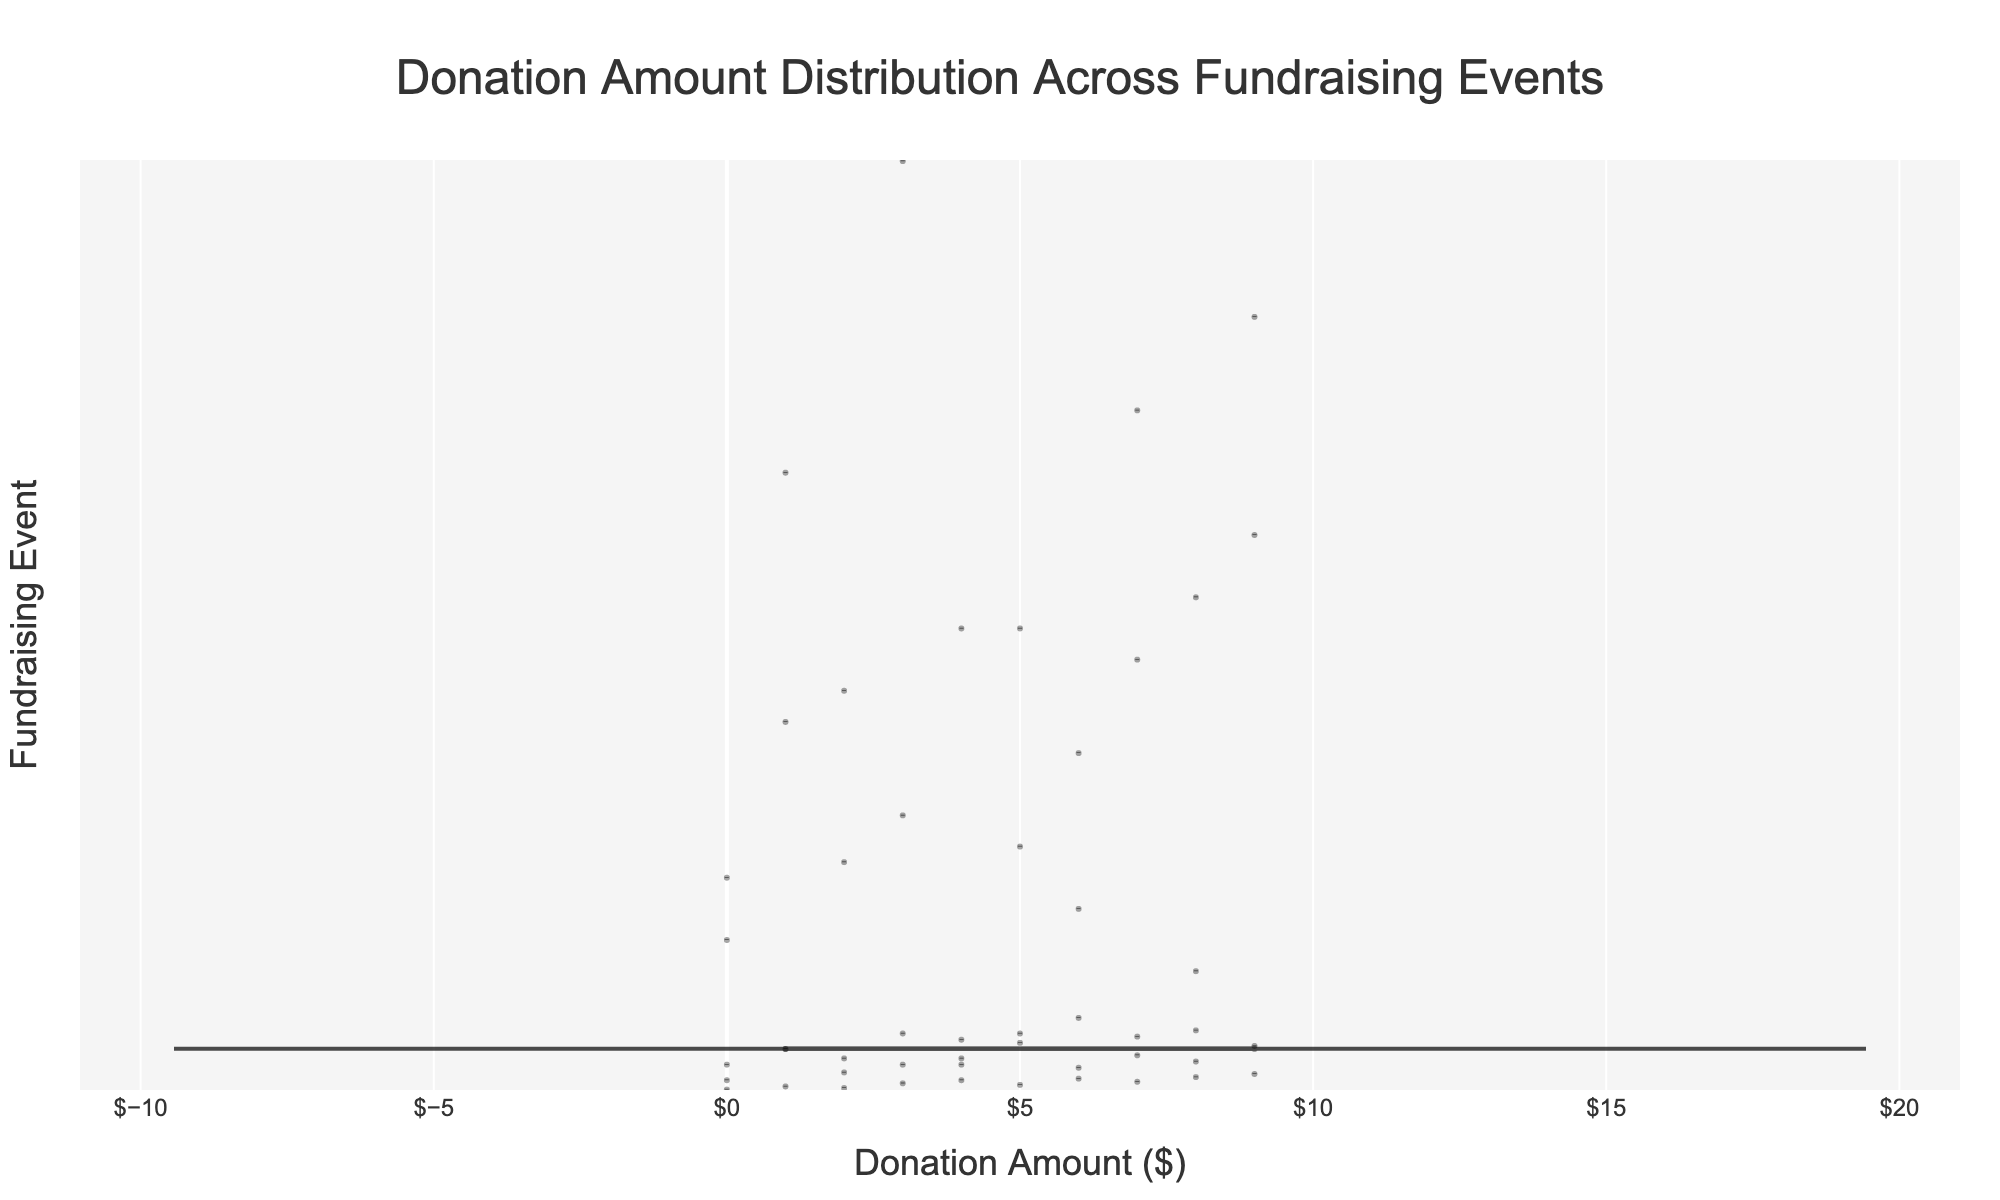What is the title of the figure? The title of the figure is usually placed at the top of the chart and describes the main topic of the visualization. In this case, it should clearly state what the chart is about.
Answer: Donation Amount Distribution Across Fundraising Events What does the x-axis represent? The x-axis typically represents the measurement scale in a violin plot. Here, after looking at the chart, the x-axis is labeled with a monetary value, indicating it represents the donation amounts.
Answer: Donation Amount ($) What does the y-axis represent? The y-axis typically denotes the categories or groups in a violin plot. In the chart, the various fundraising events appear on the y-axis, indicating it represents the different fundraising events.
Answer: Fundraising Event Which fundraising event has the widest range of donation amounts? To determine the event with the widest range of donation amounts, observe the horizontal spread of the violins. The longest width from the minimum to maximum donation indicates the widest range. After checking, “Charity Gala” has the widest spread.
Answer: Charity Gala Which event has the smallest spread in donation amounts? To determine the event with the smallest spread of donation amounts, observe the horizontal span of the violins. The event with the shortest horizontal length indicates the smallest spread. The "Online Campaign" appears to have the smallest spread.
Answer: Online Campaign What is the median donation amount for the Charity Gala? The median is indicated by a line inside the violin plot. In this case, locate the central line within the Charity Gala's violin plot to determine its median.
Answer: $1250 How do the median donation amounts for Walkathon and Silent Auction compare? To compare the medians, find the central line in the violin plots for Walkathon and Silent Auction and compare their x-axis positions. Walkathon’s median appears lower than that of the Silent Auction.
Answer: Walkathon's median is lower than Silent Auction's Which event has the highest average donation amount? To determine the event with the highest average, look for the mean line within each violin plot, which is often represented differently, or use any relevant summary statistics shown in the plot. After observing, "Charity Gala" has the highest average donation amount.
Answer: Charity Gala Which event has outliers in its donation distribution, and how are they represented? Outliers are often represented as individual points outside the main body of a violin plot. Check the figure for events with points separated from the main distribution. Both "Charity Gala" and "Auction Dinner" show visible outliers.
Answer: Charity Gala and Auction Dinner 